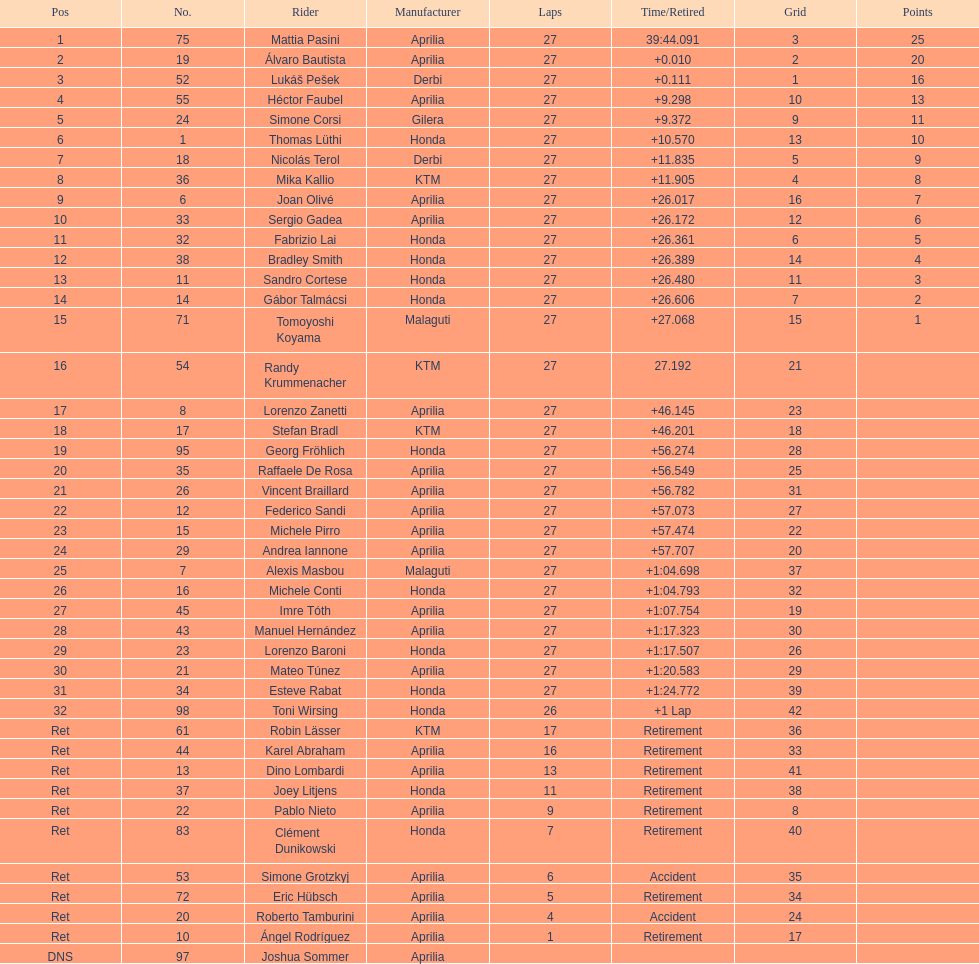How many racers did not use an aprilia or a honda? 9. I'm looking to parse the entire table for insights. Could you assist me with that? {'header': ['Pos', 'No.', 'Rider', 'Manufacturer', 'Laps', 'Time/Retired', 'Grid', 'Points'], 'rows': [['1', '75', 'Mattia Pasini', 'Aprilia', '27', '39:44.091', '3', '25'], ['2', '19', 'Álvaro Bautista', 'Aprilia', '27', '+0.010', '2', '20'], ['3', '52', 'Lukáš Pešek', 'Derbi', '27', '+0.111', '1', '16'], ['4', '55', 'Héctor Faubel', 'Aprilia', '27', '+9.298', '10', '13'], ['5', '24', 'Simone Corsi', 'Gilera', '27', '+9.372', '9', '11'], ['6', '1', 'Thomas Lüthi', 'Honda', '27', '+10.570', '13', '10'], ['7', '18', 'Nicolás Terol', 'Derbi', '27', '+11.835', '5', '9'], ['8', '36', 'Mika Kallio', 'KTM', '27', '+11.905', '4', '8'], ['9', '6', 'Joan Olivé', 'Aprilia', '27', '+26.017', '16', '7'], ['10', '33', 'Sergio Gadea', 'Aprilia', '27', '+26.172', '12', '6'], ['11', '32', 'Fabrizio Lai', 'Honda', '27', '+26.361', '6', '5'], ['12', '38', 'Bradley Smith', 'Honda', '27', '+26.389', '14', '4'], ['13', '11', 'Sandro Cortese', 'Honda', '27', '+26.480', '11', '3'], ['14', '14', 'Gábor Talmácsi', 'Honda', '27', '+26.606', '7', '2'], ['15', '71', 'Tomoyoshi Koyama', 'Malaguti', '27', '+27.068', '15', '1'], ['16', '54', 'Randy Krummenacher', 'KTM', '27', '27.192', '21', ''], ['17', '8', 'Lorenzo Zanetti', 'Aprilia', '27', '+46.145', '23', ''], ['18', '17', 'Stefan Bradl', 'KTM', '27', '+46.201', '18', ''], ['19', '95', 'Georg Fröhlich', 'Honda', '27', '+56.274', '28', ''], ['20', '35', 'Raffaele De Rosa', 'Aprilia', '27', '+56.549', '25', ''], ['21', '26', 'Vincent Braillard', 'Aprilia', '27', '+56.782', '31', ''], ['22', '12', 'Federico Sandi', 'Aprilia', '27', '+57.073', '27', ''], ['23', '15', 'Michele Pirro', 'Aprilia', '27', '+57.474', '22', ''], ['24', '29', 'Andrea Iannone', 'Aprilia', '27', '+57.707', '20', ''], ['25', '7', 'Alexis Masbou', 'Malaguti', '27', '+1:04.698', '37', ''], ['26', '16', 'Michele Conti', 'Honda', '27', '+1:04.793', '32', ''], ['27', '45', 'Imre Tóth', 'Aprilia', '27', '+1:07.754', '19', ''], ['28', '43', 'Manuel Hernández', 'Aprilia', '27', '+1:17.323', '30', ''], ['29', '23', 'Lorenzo Baroni', 'Honda', '27', '+1:17.507', '26', ''], ['30', '21', 'Mateo Túnez', 'Aprilia', '27', '+1:20.583', '29', ''], ['31', '34', 'Esteve Rabat', 'Honda', '27', '+1:24.772', '39', ''], ['32', '98', 'Toni Wirsing', 'Honda', '26', '+1 Lap', '42', ''], ['Ret', '61', 'Robin Lässer', 'KTM', '17', 'Retirement', '36', ''], ['Ret', '44', 'Karel Abraham', 'Aprilia', '16', 'Retirement', '33', ''], ['Ret', '13', 'Dino Lombardi', 'Aprilia', '13', 'Retirement', '41', ''], ['Ret', '37', 'Joey Litjens', 'Honda', '11', 'Retirement', '38', ''], ['Ret', '22', 'Pablo Nieto', 'Aprilia', '9', 'Retirement', '8', ''], ['Ret', '83', 'Clément Dunikowski', 'Honda', '7', 'Retirement', '40', ''], ['Ret', '53', 'Simone Grotzkyj', 'Aprilia', '6', 'Accident', '35', ''], ['Ret', '72', 'Eric Hübsch', 'Aprilia', '5', 'Retirement', '34', ''], ['Ret', '20', 'Roberto Tamburini', 'Aprilia', '4', 'Accident', '24', ''], ['Ret', '10', 'Ángel Rodríguez', 'Aprilia', '1', 'Retirement', '17', ''], ['DNS', '97', 'Joshua Sommer', 'Aprilia', '', '', '', '']]} 